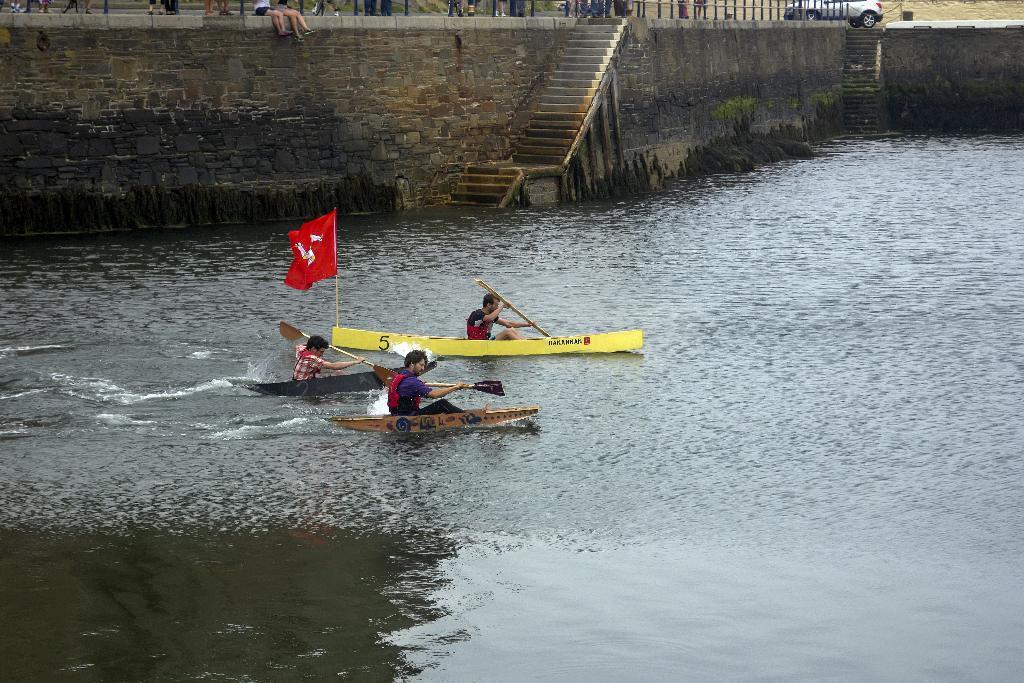In one or two sentences, can you explain what this image depicts? Above this water there are three boats. These three people are holding paddles and sitting on these boats. On this yellow boat there is a red flag. Background there are steps, vehicle and people legs.  